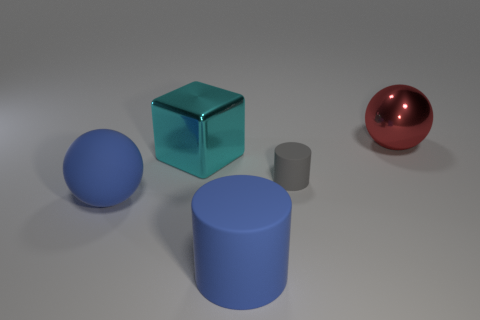Is the number of gray objects that are in front of the blue rubber cylinder less than the number of cylinders?
Keep it short and to the point. Yes. What is the color of the large sphere to the left of the big ball behind the blue matte object that is to the left of the large cyan shiny object?
Offer a very short reply. Blue. What is the size of the other thing that is the same shape as the tiny matte thing?
Ensure brevity in your answer.  Large. Are there fewer shiny spheres behind the matte ball than big things in front of the gray matte object?
Make the answer very short. Yes. There is a object that is to the left of the big blue rubber cylinder and in front of the gray rubber object; what is its shape?
Keep it short and to the point. Sphere. What is the size of the red sphere that is made of the same material as the big cyan cube?
Your response must be concise. Large. There is a large matte cylinder; does it have the same color as the sphere that is in front of the large red thing?
Offer a terse response. Yes. There is a big object that is both on the right side of the big shiny cube and in front of the red metallic ball; what material is it?
Ensure brevity in your answer.  Rubber. There is a object that is the same color as the large matte cylinder; what size is it?
Ensure brevity in your answer.  Large. Do the thing on the right side of the gray cylinder and the blue thing that is behind the blue rubber cylinder have the same shape?
Offer a very short reply. Yes. 